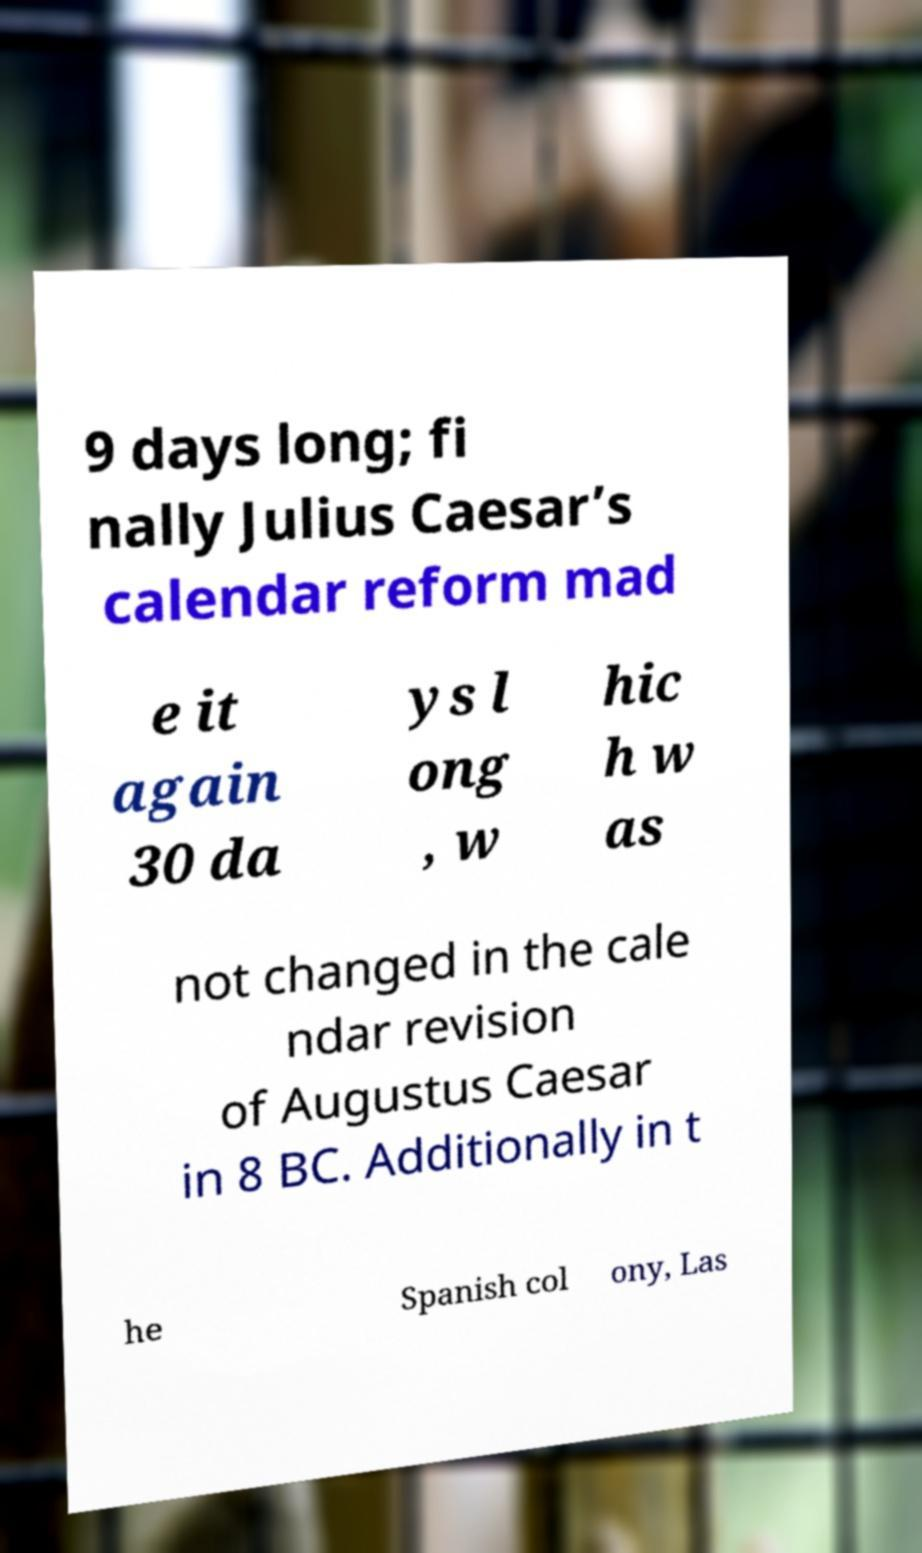I need the written content from this picture converted into text. Can you do that? 9 days long; fi nally Julius Caesar’s calendar reform mad e it again 30 da ys l ong , w hic h w as not changed in the cale ndar revision of Augustus Caesar in 8 BC. Additionally in t he Spanish col ony, Las 